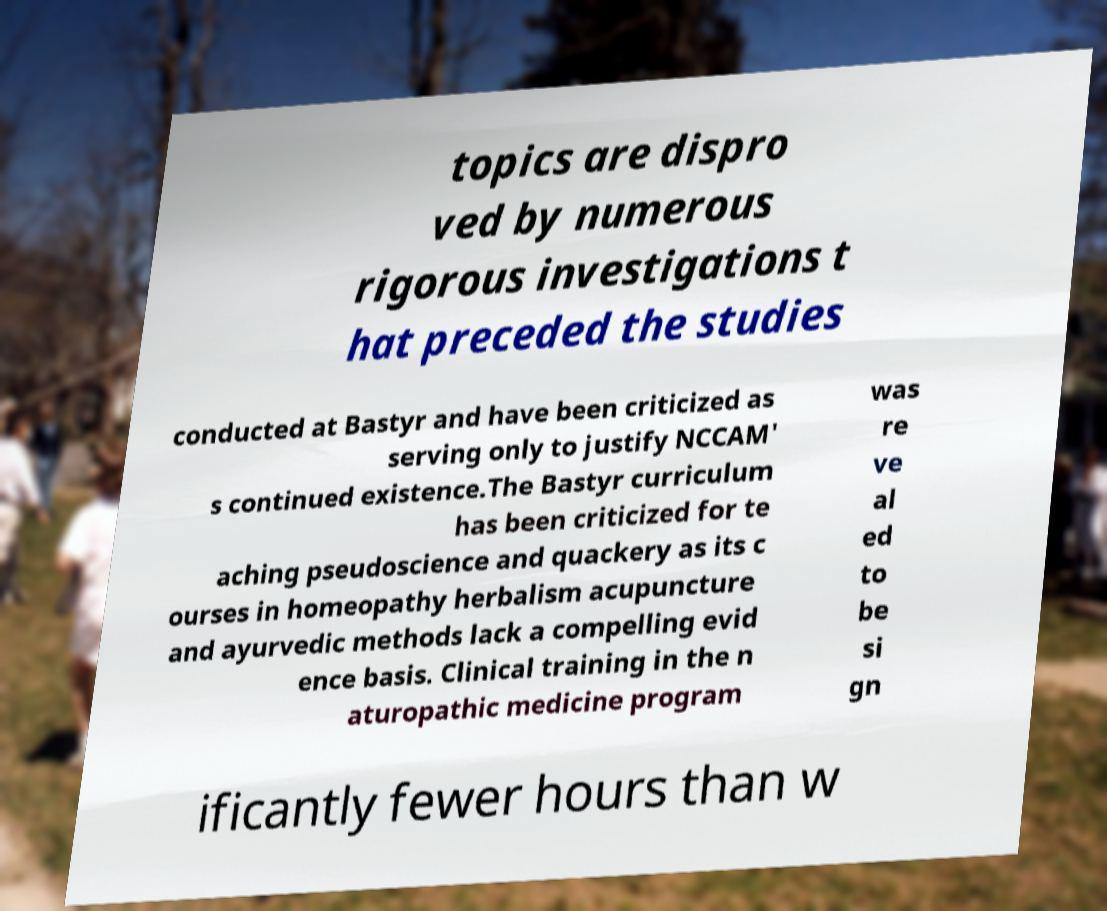Can you read and provide the text displayed in the image?This photo seems to have some interesting text. Can you extract and type it out for me? topics are dispro ved by numerous rigorous investigations t hat preceded the studies conducted at Bastyr and have been criticized as serving only to justify NCCAM' s continued existence.The Bastyr curriculum has been criticized for te aching pseudoscience and quackery as its c ourses in homeopathy herbalism acupuncture and ayurvedic methods lack a compelling evid ence basis. Clinical training in the n aturopathic medicine program was re ve al ed to be si gn ificantly fewer hours than w 